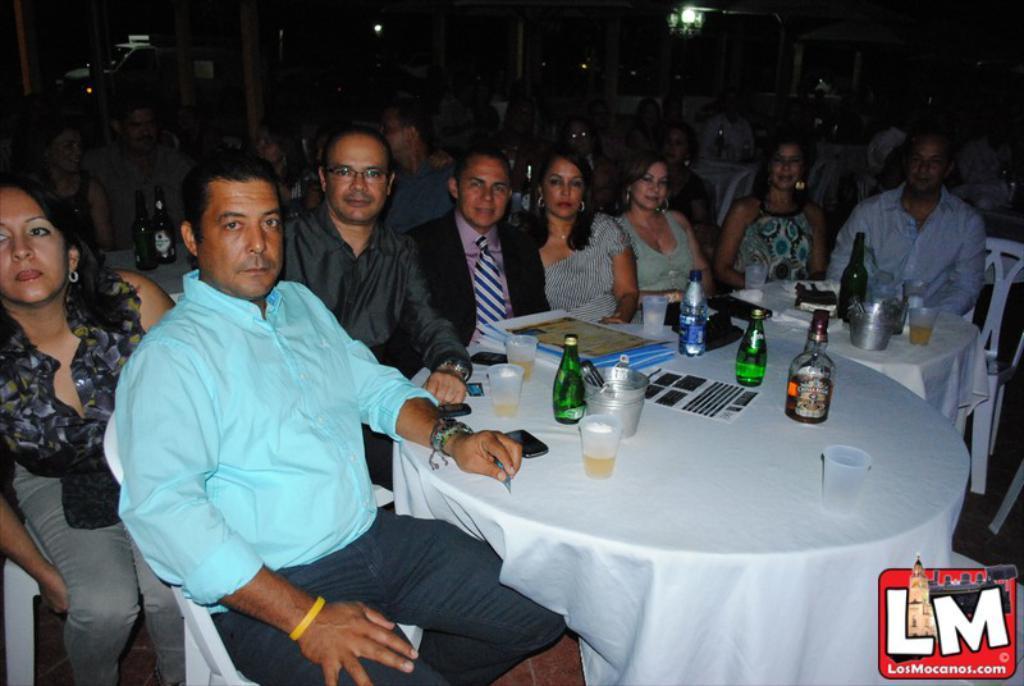In one or two sentences, can you explain what this image depicts? In this picture we can see all the persons sitting on chairs in front of a table and on the table we can see glasses, bottles, and mobile. There is a white cloth on the table and on the background we can see one vehicle. 